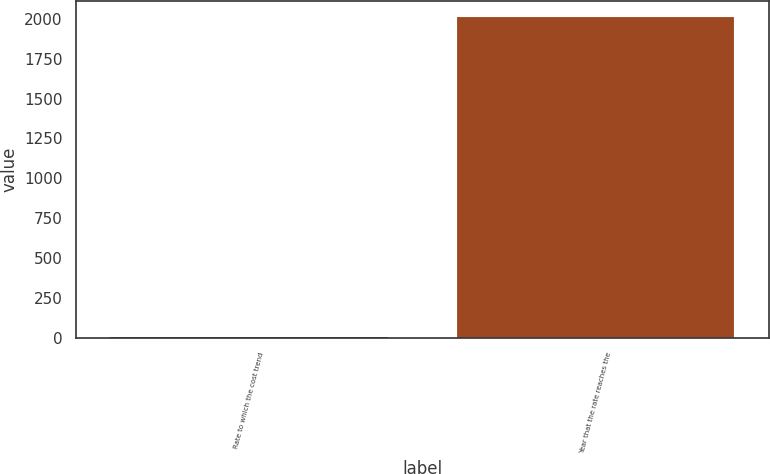Convert chart. <chart><loc_0><loc_0><loc_500><loc_500><bar_chart><fcel>Rate to which the cost trend<fcel>Year that the rate reaches the<nl><fcel>5<fcel>2012<nl></chart> 